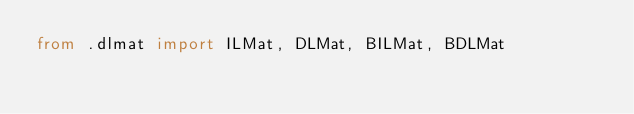<code> <loc_0><loc_0><loc_500><loc_500><_Python_>from .dlmat import ILMat, DLMat, BILMat, BDLMat
</code> 